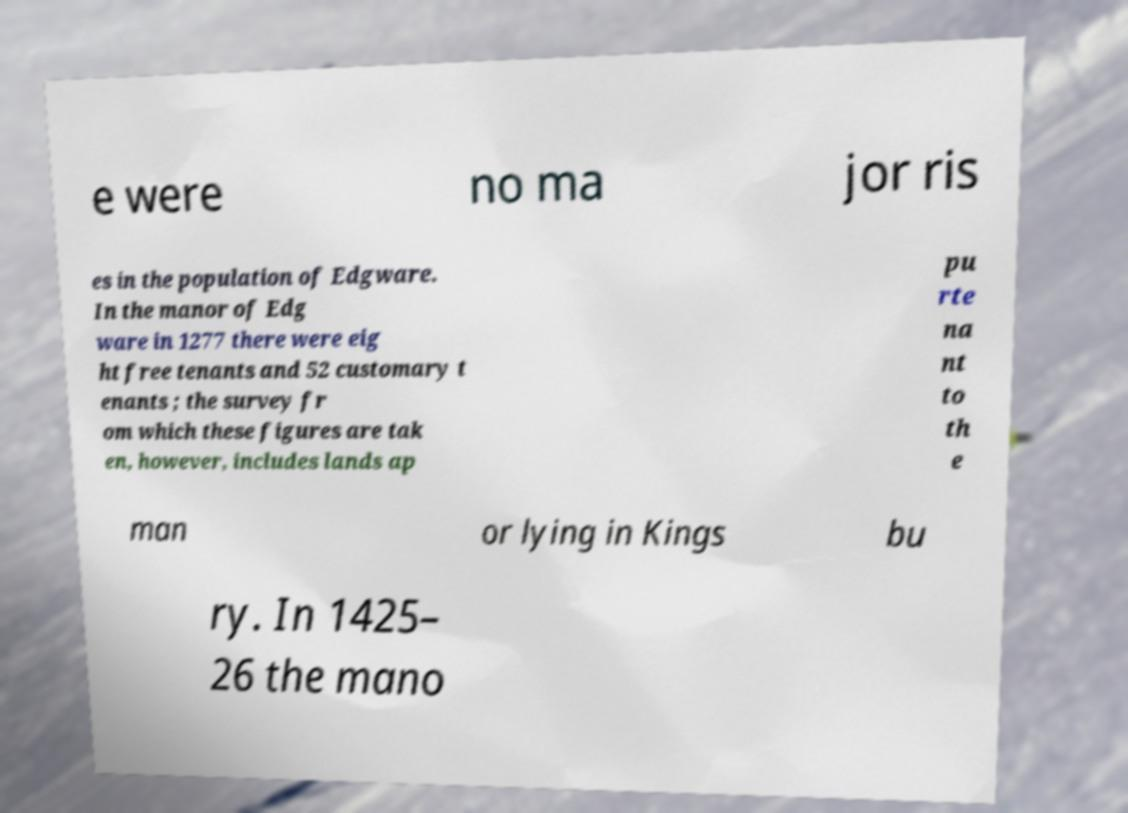I need the written content from this picture converted into text. Can you do that? e were no ma jor ris es in the population of Edgware. In the manor of Edg ware in 1277 there were eig ht free tenants and 52 customary t enants ; the survey fr om which these figures are tak en, however, includes lands ap pu rte na nt to th e man or lying in Kings bu ry. In 1425– 26 the mano 